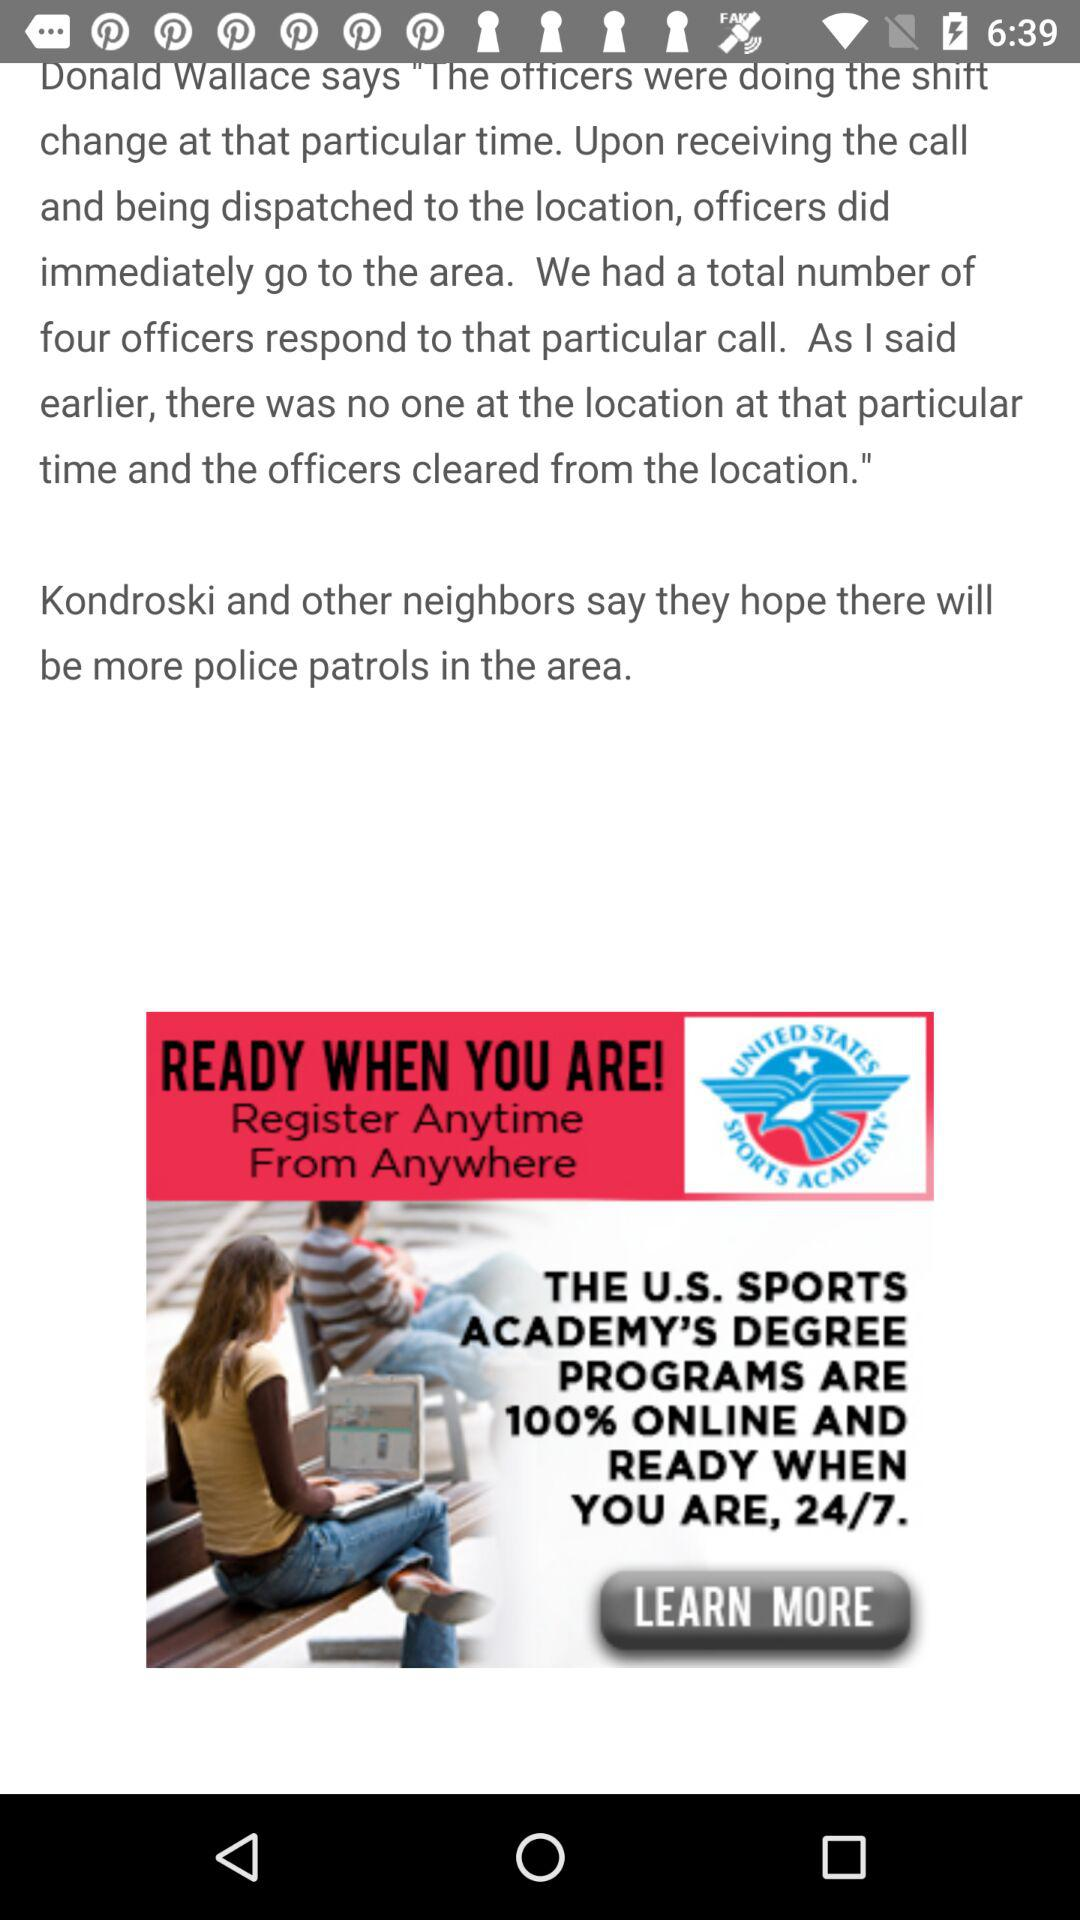How many officers respond to that particular call? The number of officers is four. 